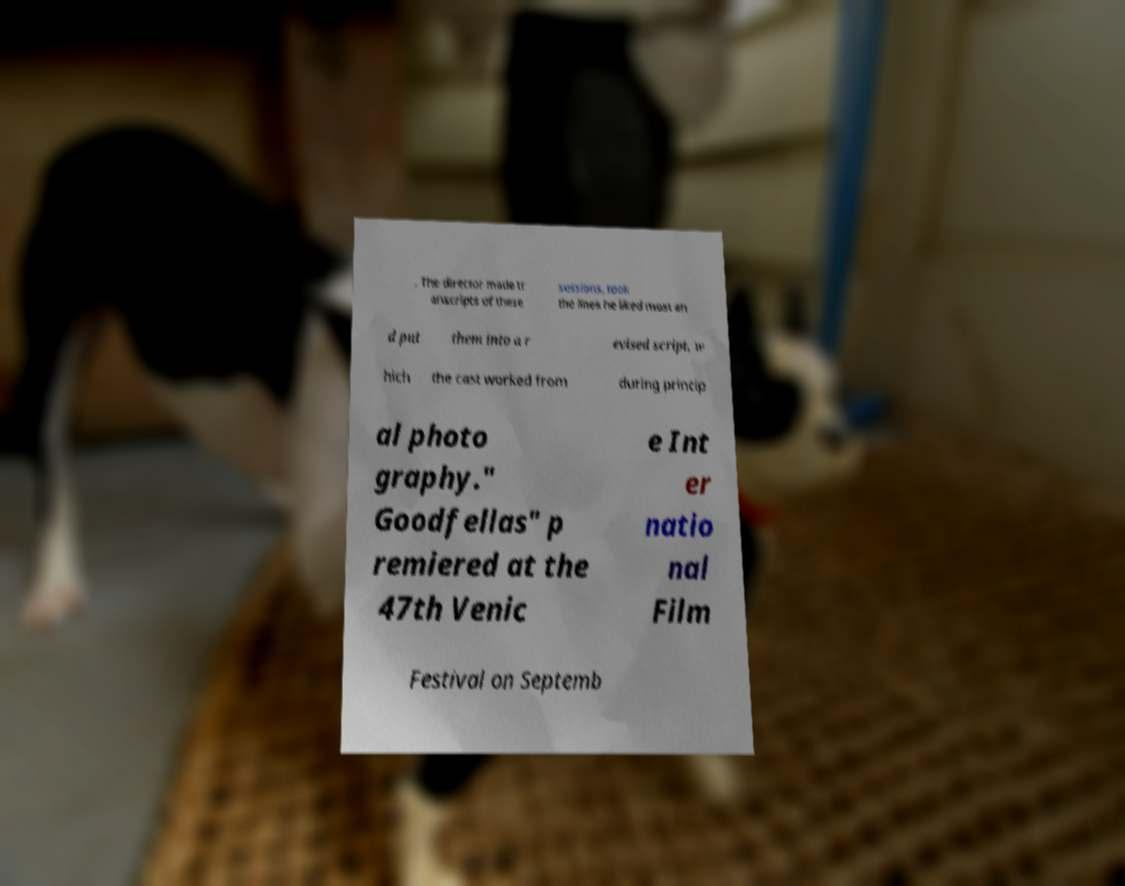Could you extract and type out the text from this image? . The director made tr anscripts of these sessions, took the lines he liked most an d put them into a r evised script, w hich the cast worked from during princip al photo graphy." Goodfellas" p remiered at the 47th Venic e Int er natio nal Film Festival on Septemb 